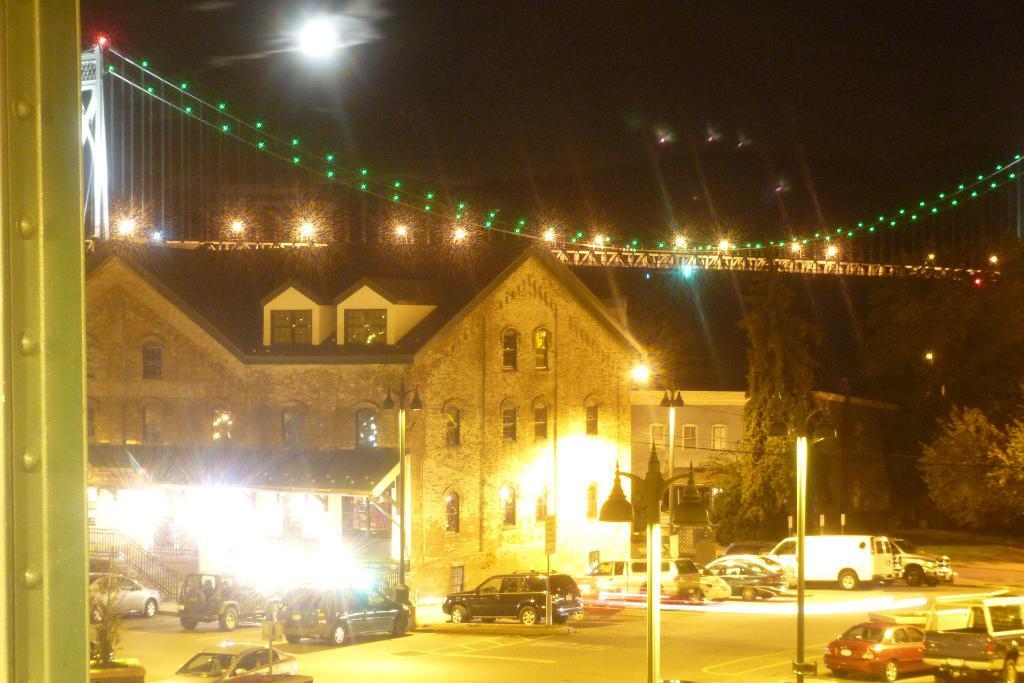Can you describe this image briefly? In this image I can see the road. And there are many vehicles to the side of the road and these are in different colors. To the side of the vehicles I can see the building and the trees. In the back I can see many lights and the sky. 